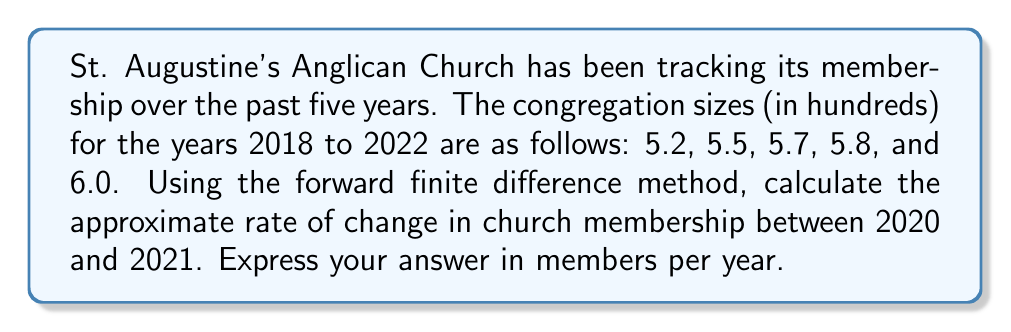Show me your answer to this math problem. To solve this problem, we'll use the forward finite difference method to approximate the rate of change in church membership. This method is particularly fitting for our Anglican context, as it allows us to discern the growth of our spiritual community over time.

Step 1: Identify the relevant data points
For 2020: $f(x_0) = 5.7$ hundred members
For 2021: $f(x_1) = 5.8$ hundred members

Step 2: Determine the time step (h)
The time step is 1 year.

Step 3: Apply the forward finite difference formula
The forward finite difference formula is:

$$f'(x) \approx \frac{f(x+h) - f(x)}{h}$$

Where:
$f'(x)$ is the approximate rate of change
$f(x+h)$ is the function value at the next point
$f(x)$ is the function value at the current point
$h$ is the step size

Substituting our values:

$$f'(2020) \approx \frac{f(2021) - f(2020)}{1}$$
$$f'(2020) \approx \frac{5.8 - 5.7}{1}$$
$$f'(2020) \approx 0.1$$

Step 4: Interpret the result
The result 0.1 is in hundreds of members per year. To convert to members per year, we multiply by 100:

$$0.1 \times 100 = 10$$

Therefore, the approximate rate of change in church membership between 2020 and 2021 is 10 members per year.
Answer: 10 members/year 